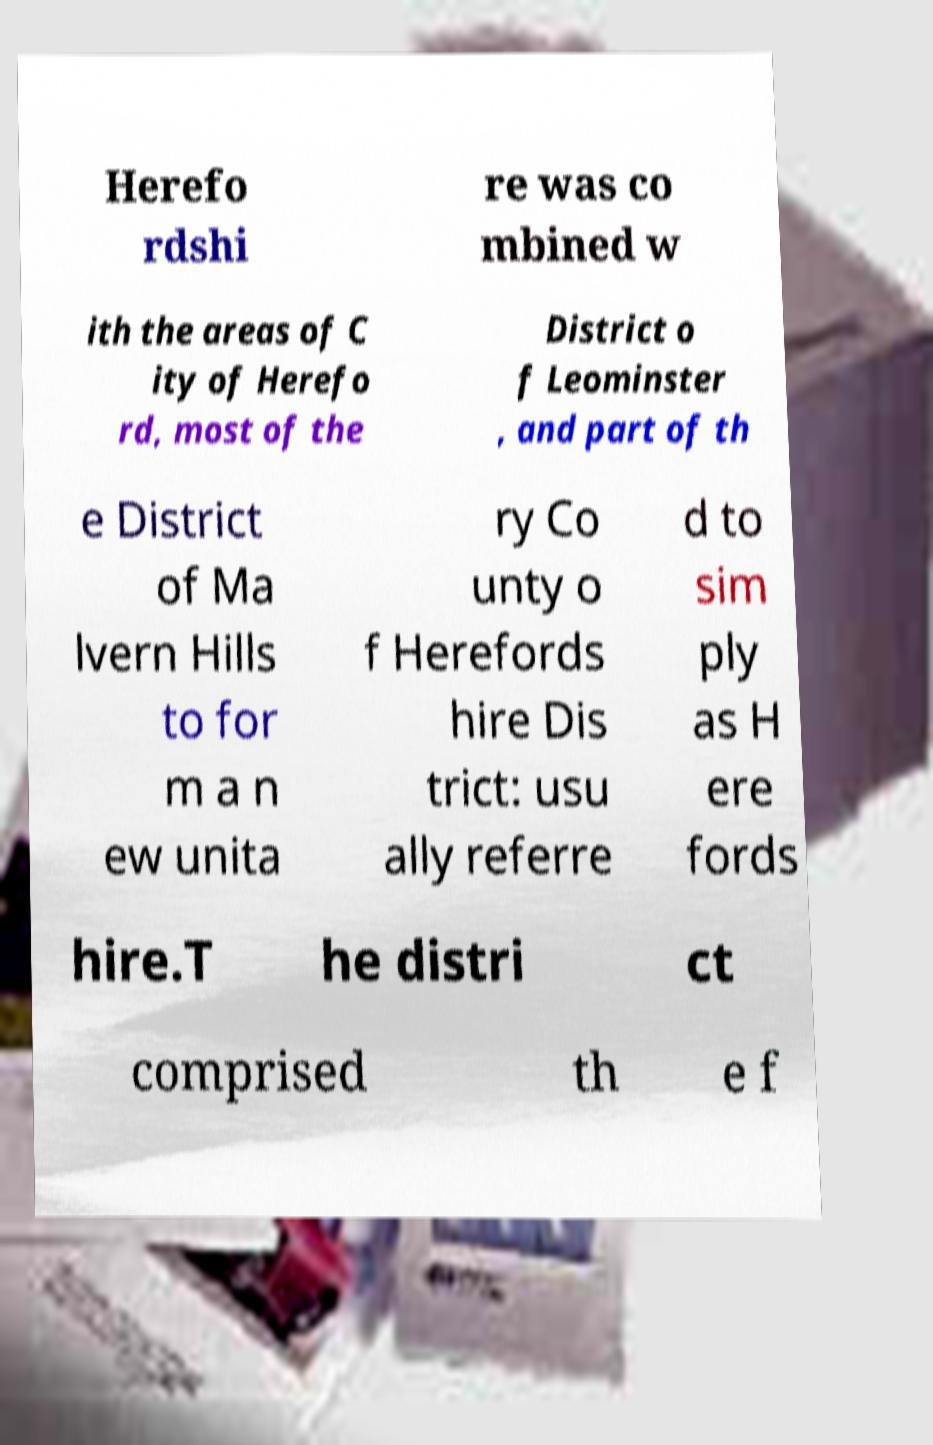Could you extract and type out the text from this image? Herefo rdshi re was co mbined w ith the areas of C ity of Herefo rd, most of the District o f Leominster , and part of th e District of Ma lvern Hills to for m a n ew unita ry Co unty o f Herefords hire Dis trict: usu ally referre d to sim ply as H ere fords hire.T he distri ct comprised th e f 